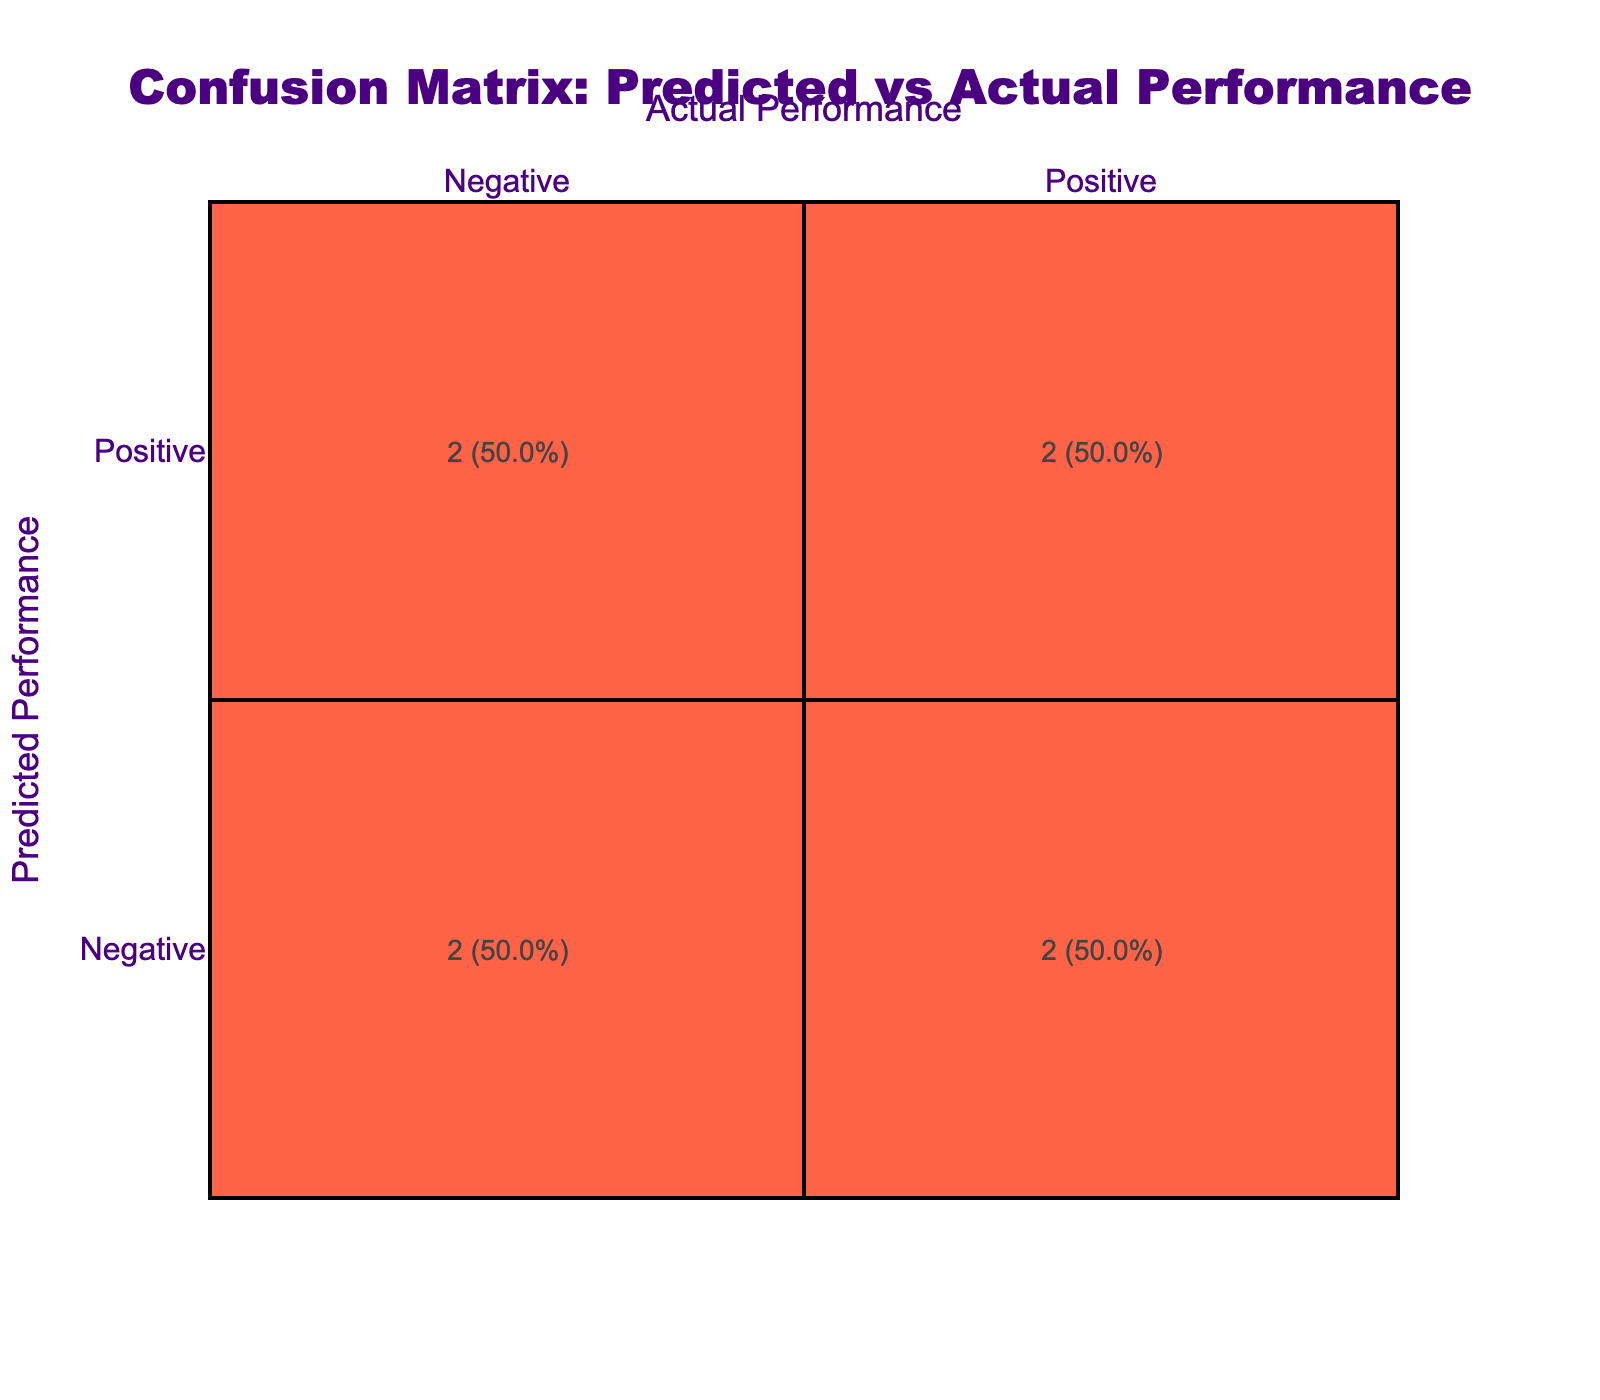What is the total number of films predicted as Positive? There are three films predicted as Positive: "The Latest Adventure," "Space Odyssey," and "Love in Paris." Therefore, the total count is three.
Answer: 3 What percentage of films were correctly predicted as Negative? There are four films predicted as Negative, and two of these were actually Negative: "Dark Secrets" and "Cooking with Chaos." To find the percentage, divide the correct predictions (2) by total Negative predictions (4) and multiply by 100: (2/4) * 100 = 50%.
Answer: 50% Is it true that the film "Space Odyssey" was predicted correctly? The actual performance of "Space Odyssey" is Positive, and the predicted performance is also Positive. Therefore, it was predicted correctly.
Answer: Yes What film has the highest correct prediction rate combined for Positive performances? The films predicted as Positive are two: "The Latest Adventure," and "Space Odyssey," both correct predictions. "Love in Paris," is a Negative prediction with a Positive outcome, so it does not count. Therefore, the correct rate is 100% for "The Latest Adventure" and "Space Odyssey."
Answer: "The Latest Adventure" and "Space Odyssey" How many films had a mismatch between predicted and actual performance? The films causing a mismatch between the predicted and actual performances are "Superhero Origins" (Positive/Negative), "Love in Paris" (Negative/Positive), and "The Art of Deception" (Positive/Negative). There are three films in total that had a mismatch.
Answer: 3 What is the overall rate of films predicted correctly based on the actual performances? To calculate the overall rate, count all correct predictions: "The Latest Adventure," "Dark Secrets," "Cooking with Chaos," and "Space Odyssey" are all correct, totaling four. There are eight films altogether, so the rate is (4/8) * 100 = 50%.
Answer: 50% Which main actor had a film with a negative prediction that was actually positive? The film "Epic Reunion," starring Meryl Streep, had a prediction of Negative but was actually Positive performance.
Answer: Meryl Streep What is the average performance of films predicted as Negative? The films predicted as Negative are: "Dark Secrets," "Cooking with Chaos," and "The Art of Deception," with actual performances being Negative or Positive. The average performance calculation for negatives would be: 2 negatives out of 3 predictions, thus 2/3 * 100 = ~67%.
Answer: ~67% 